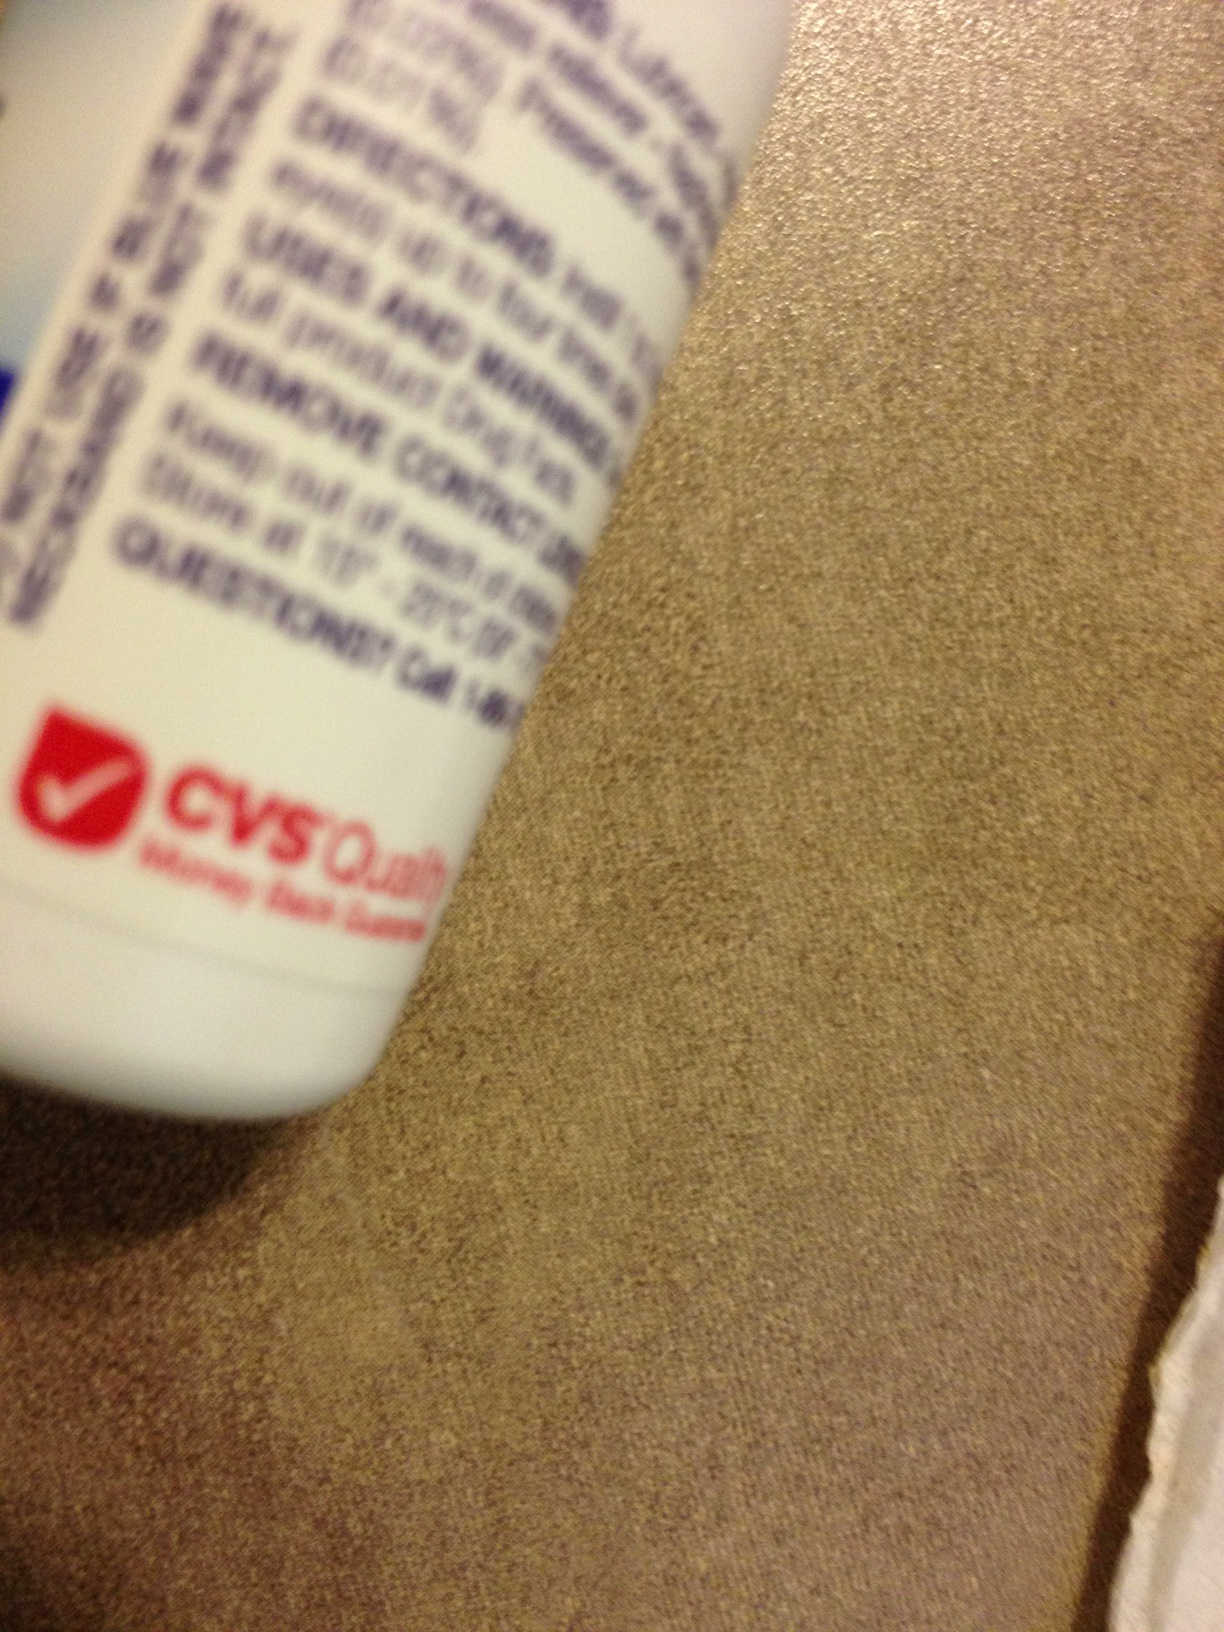Is this bottle liquid tears? Based on the image provided, it is not possible to conclusively determine the contents of the bottle. However, the label partially shown seems to belong to a CVS product, and if it is indeed liquid tears, that would typically refer to a type of eye drops used for lubricating the eyes to relieve dryness and irritation. 